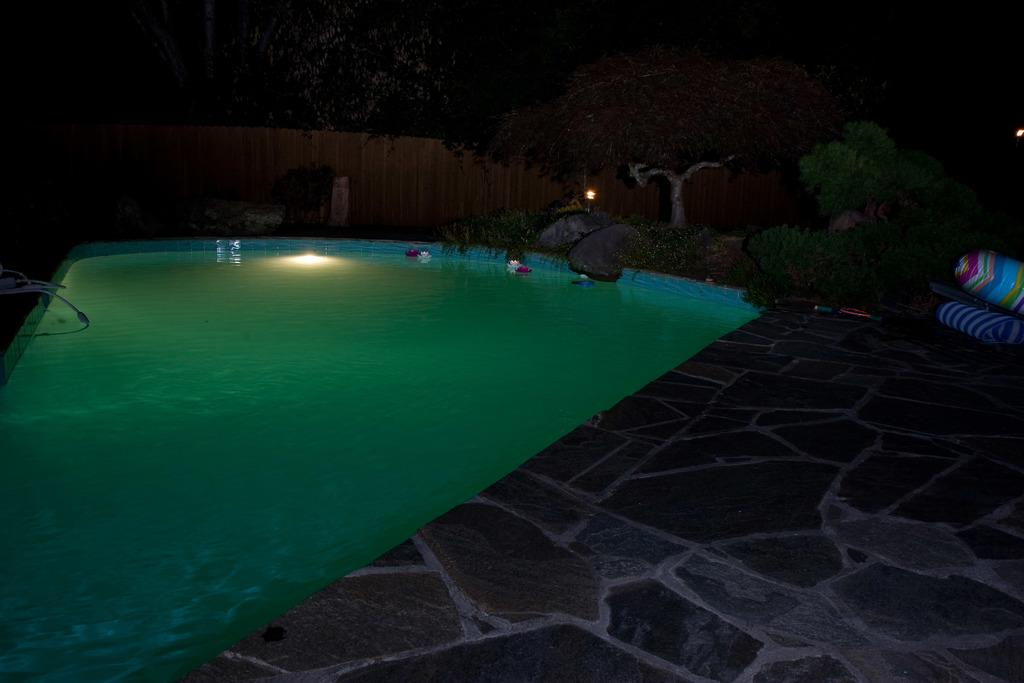What is the main feature in the image? There is a swimming pool in the image. What can be seen beside the swimming pool? There are trees beside the swimming pool in the image. What type of furniture is visible in the image? There is no furniture present in the image. What type of educational structure is visible in the image? There is no educational structure present in the image. 